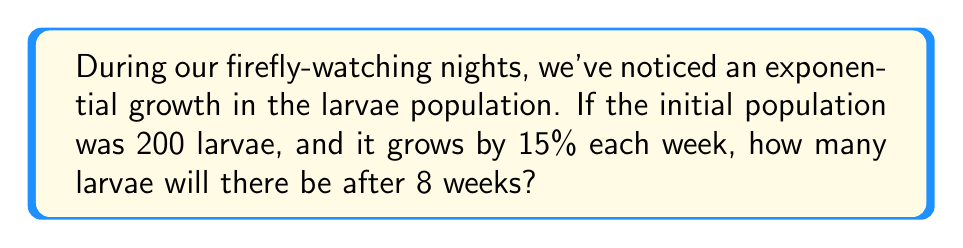Provide a solution to this math problem. Let's approach this step-by-step:

1) The exponential growth function is given by:
   $$P(t) = P_0 \cdot (1 + r)^t$$
   Where:
   $P(t)$ is the population at time $t$
   $P_0$ is the initial population
   $r$ is the growth rate
   $t$ is the time period

2) We know:
   $P_0 = 200$ (initial population)
   $r = 0.15$ (15% growth rate)
   $t = 8$ (weeks)

3) Plugging these values into our equation:
   $$P(8) = 200 \cdot (1 + 0.15)^8$$

4) Simplify inside the parentheses:
   $$P(8) = 200 \cdot (1.15)^8$$

5) Calculate $(1.15)^8$:
   $$(1.15)^8 \approx 3.0590$$

6) Multiply:
   $$200 \cdot 3.0590 \approx 611.8$$

7) Since we can't have a fractional number of larvae, we round to the nearest whole number.
Answer: 612 larvae 